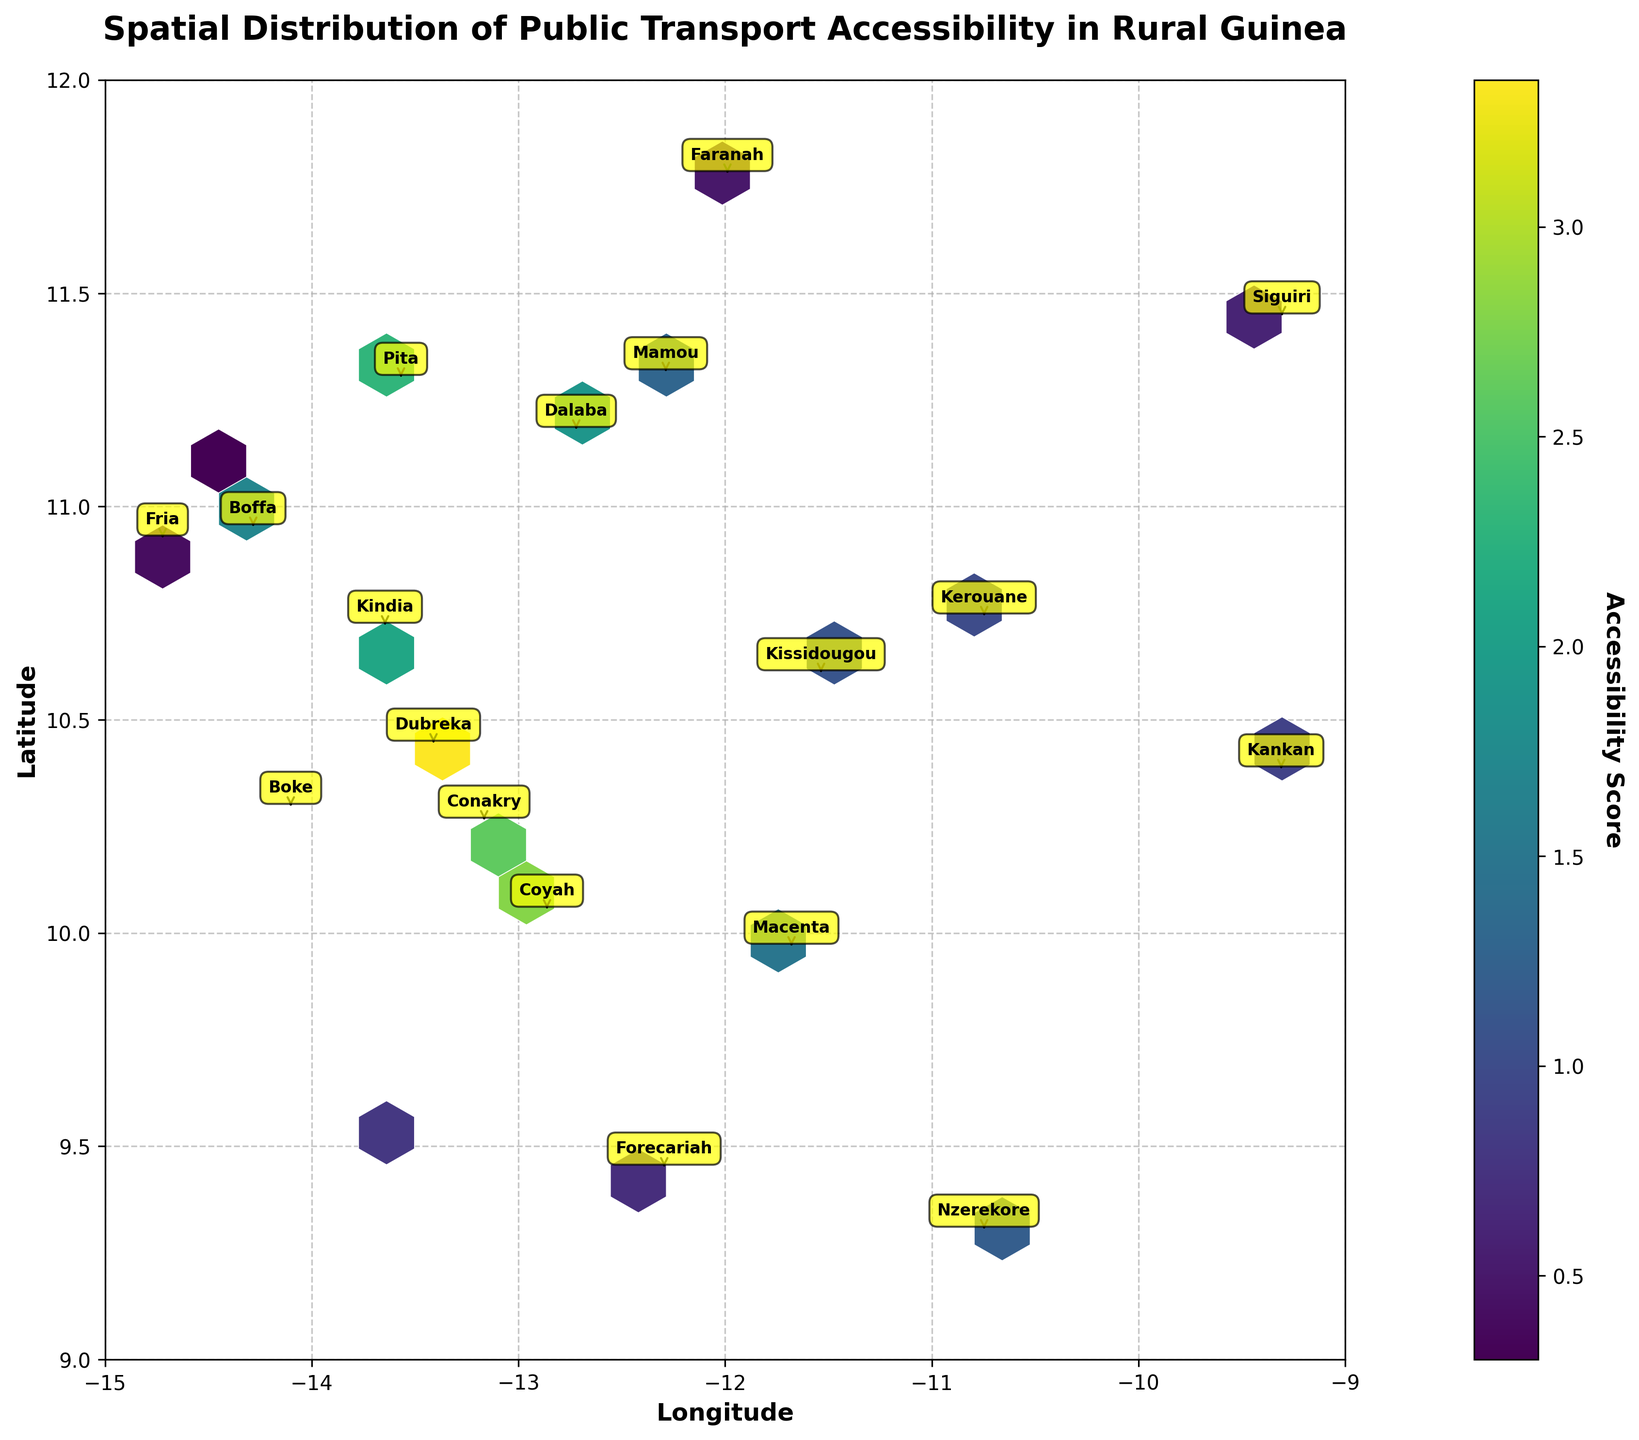what is the title of the figure? The title is displayed prominently at the top of the figure. It reads "Spatial Distribution of Public Transport Accessibility in Rural Guinea."
Answer: Spatial Distribution of Public Transport Accessibility in Rural Guinea What does the color bar represent? The color bar on the right side of the plot indicates the "Accessibility Score," showing the range of scores with a gradient from low to high.
Answer: Accessibility Score Which region appears to have the highest average accessibility score? By observing the hexbin plot, the region with the brightest (light green) coloration signifies the highest accessibility. Upon viewing, Conakry's area (between roughly -13.5 to -13 longitude and 10 to 11 latitude) shows higher scores.
Answer: Conakry Which areas show low public transport accessibility? The dark purple/blue areas in the hexbin plot represent low accessibility scores. Regions such as Boffa, Kerouane, and Siguiri fall into this category, based on their positioning in these darker zones.
Answer: Boffa, Kerouane, Siguiri What are the latitude and longitude ranges covered by the figure? The figure's axes denote the latitude and longitude scales. The range for latitude is 9 to 12, and for longitude, it’s from -15 to -9.
Answer: Latitude: 9 to 12, Longitude: -15 to -9 How does the accessibility in the region of Kindia compare to that of Nzerekore? The color and concentration of hexagons in Kindia are lighter (more green) compared to Nzerekore, indicating a higher accessibility score in Kindia.
Answer: Kindia has higher accessibility Which area contains more dense data points, Conakry or Faranah? The density of data points in Conakry is visually higher due to more frequent and lighter-colored hexagons compared to the sparser and darker ones in Faranah.
Answer: Conakry What annotation style is used to label regions on the plot? The regions are marked with yellow text boxes with arrows pointing to their corresponding positions on the plot.
Answer: Yellow text boxes with arrows Is Forecariah's accessibility higher than Dalaba's? By comparing the color brightness of the hexagons, Forecariah is darker (lower score) compared to Dalaba, suggesting Dalaba has a higher accessibility score.
Answer: No, Forecariah’s accessibility is lower What is the significance of the grid on the plot? The grid helps delineate areas and enhance readability, making it easier to correlate data points with their geographical locations.
Answer: To enhance readability and correlate data points 